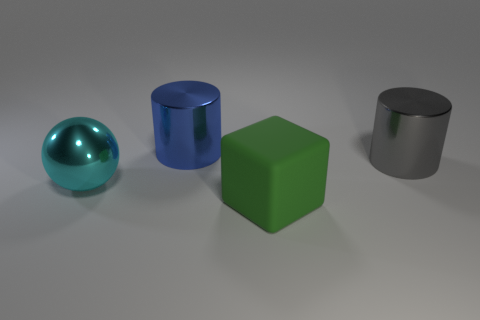Subtract 1 cylinders. How many cylinders are left? 1 Add 2 large cyan metallic things. How many objects exist? 6 Subtract all balls. How many objects are left? 3 Subtract all blue cubes. How many green balls are left? 0 Subtract all large cyan matte spheres. Subtract all large cyan things. How many objects are left? 3 Add 1 rubber blocks. How many rubber blocks are left? 2 Add 3 green objects. How many green objects exist? 4 Subtract all blue cylinders. How many cylinders are left? 1 Subtract 0 red blocks. How many objects are left? 4 Subtract all red cubes. Subtract all yellow balls. How many cubes are left? 1 